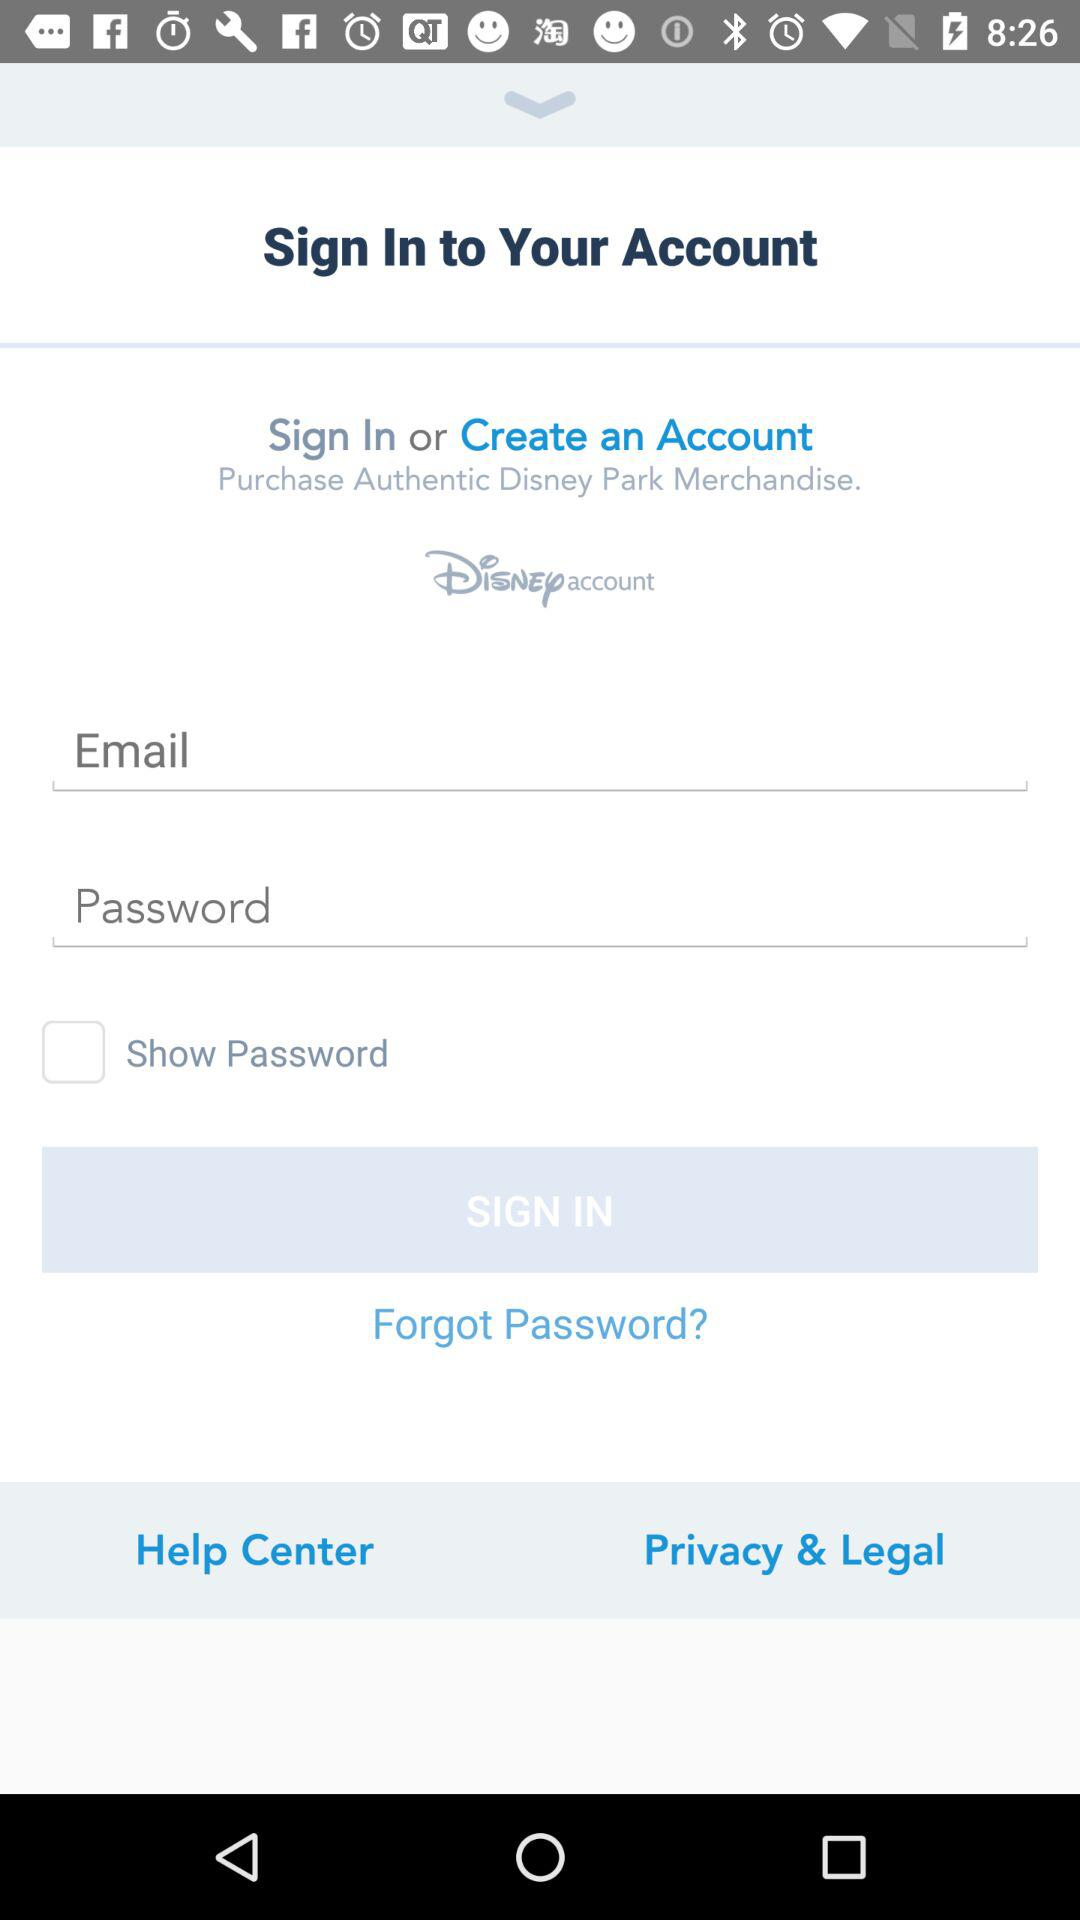What is the application name? The application name is "Disney". 